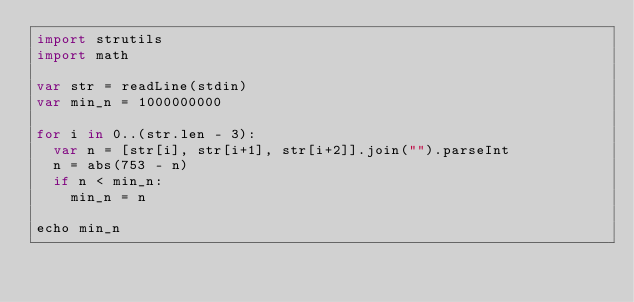Convert code to text. <code><loc_0><loc_0><loc_500><loc_500><_Nim_>import strutils
import math

var str = readLine(stdin)
var min_n = 1000000000 

for i in 0..(str.len - 3):
  var n = [str[i], str[i+1], str[i+2]].join("").parseInt
  n = abs(753 - n)
  if n < min_n:
    min_n = n 

echo min_n
</code> 